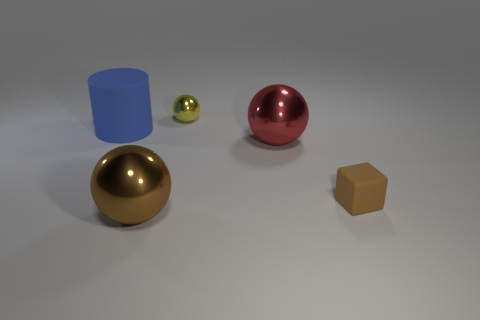Is there a large gray ball that has the same material as the tiny brown block? no 